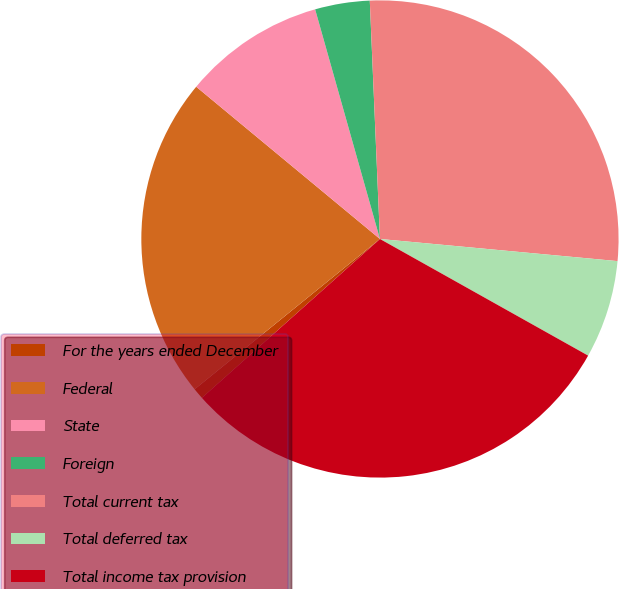<chart> <loc_0><loc_0><loc_500><loc_500><pie_chart><fcel>For the years ended December<fcel>Federal<fcel>State<fcel>Foreign<fcel>Total current tax<fcel>Total deferred tax<fcel>Total income tax provision<nl><fcel>0.75%<fcel>21.86%<fcel>9.61%<fcel>3.7%<fcel>27.16%<fcel>6.65%<fcel>30.28%<nl></chart> 